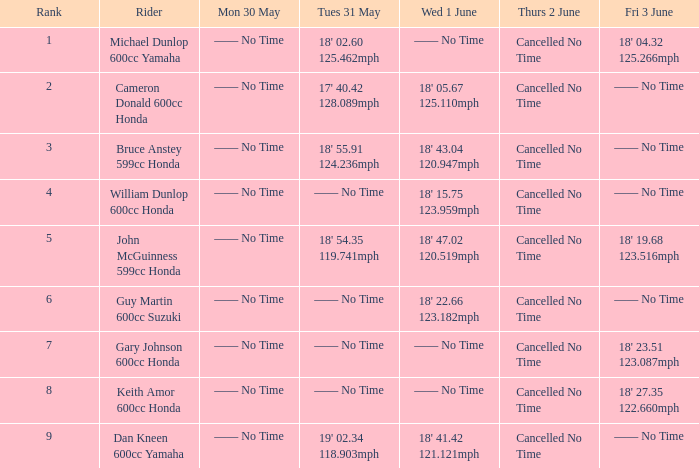Who was the rider with a Fri 3 June time of 18' 19.68 123.516mph? John McGuinness 599cc Honda. 